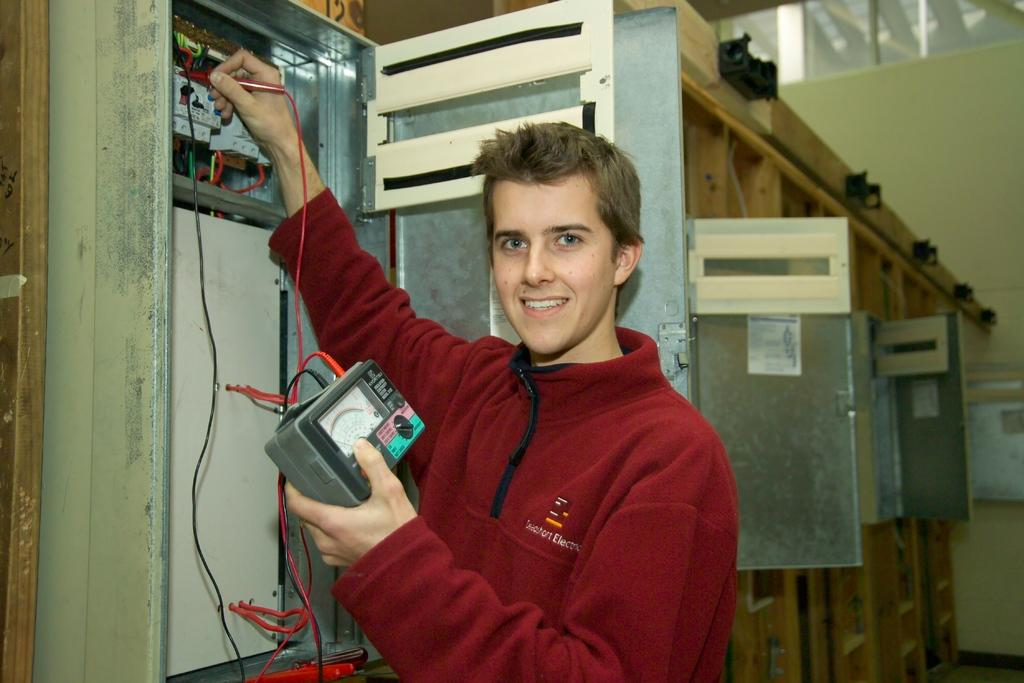Who is present in the image? There is a man in the image. What is the man doing in the image? The man is standing and smiling. What object is the man holding in the image? The man is holding a meter with wires. What can be seen in the background behind the man? There are fuse boxes visible behind the man. What type of rose is the man holding in the image? There is no rose present in the image; the man is holding a meter with wires. How many cubs are visible in the image? There are no cubs present in the image. 